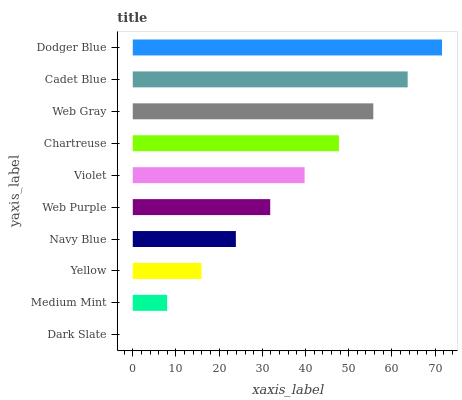Is Dark Slate the minimum?
Answer yes or no. Yes. Is Dodger Blue the maximum?
Answer yes or no. Yes. Is Medium Mint the minimum?
Answer yes or no. No. Is Medium Mint the maximum?
Answer yes or no. No. Is Medium Mint greater than Dark Slate?
Answer yes or no. Yes. Is Dark Slate less than Medium Mint?
Answer yes or no. Yes. Is Dark Slate greater than Medium Mint?
Answer yes or no. No. Is Medium Mint less than Dark Slate?
Answer yes or no. No. Is Violet the high median?
Answer yes or no. Yes. Is Web Purple the low median?
Answer yes or no. Yes. Is Cadet Blue the high median?
Answer yes or no. No. Is Yellow the low median?
Answer yes or no. No. 